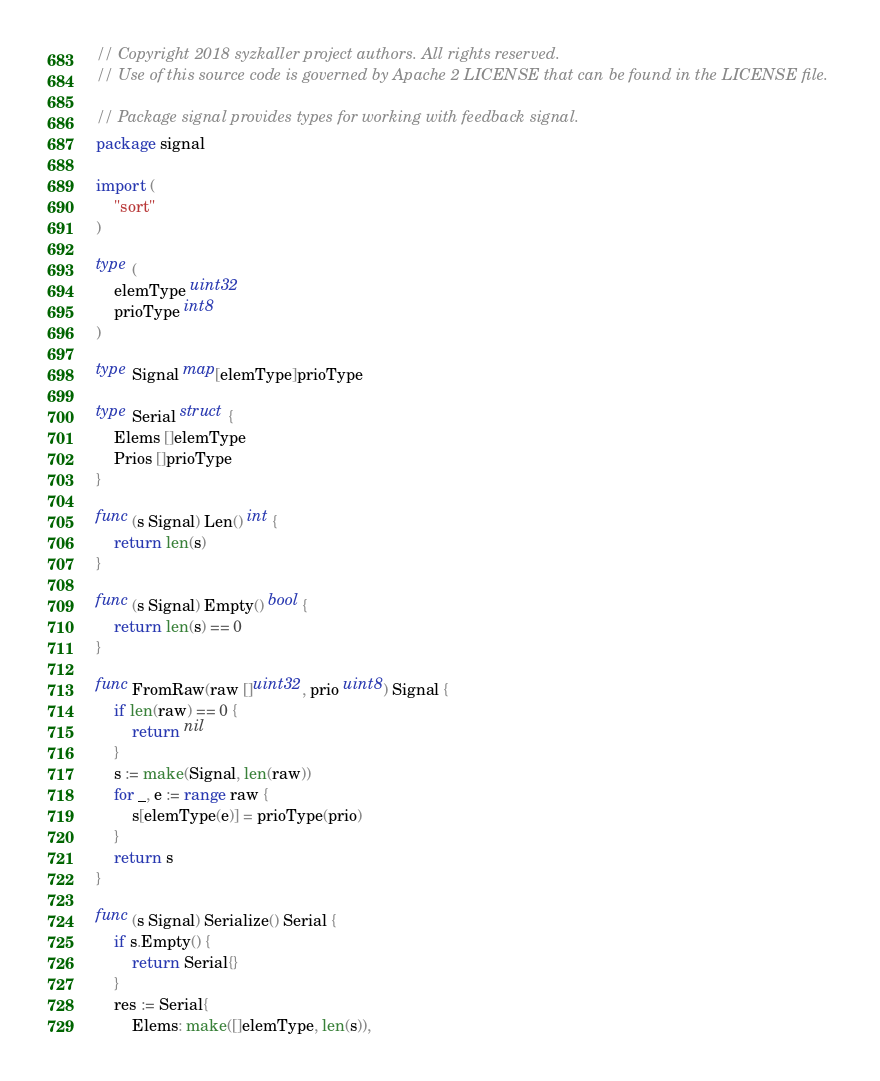Convert code to text. <code><loc_0><loc_0><loc_500><loc_500><_Go_>// Copyright 2018 syzkaller project authors. All rights reserved.
// Use of this source code is governed by Apache 2 LICENSE that can be found in the LICENSE file.

// Package signal provides types for working with feedback signal.
package signal

import (
	"sort"
)

type (
	elemType uint32
	prioType int8
)

type Signal map[elemType]prioType

type Serial struct {
	Elems []elemType
	Prios []prioType
}

func (s Signal) Len() int {
	return len(s)
}

func (s Signal) Empty() bool {
	return len(s) == 0
}

func FromRaw(raw []uint32, prio uint8) Signal {
	if len(raw) == 0 {
		return nil
	}
	s := make(Signal, len(raw))
	for _, e := range raw {
		s[elemType(e)] = prioType(prio)
	}
	return s
}

func (s Signal) Serialize() Serial {
	if s.Empty() {
		return Serial{}
	}
	res := Serial{
		Elems: make([]elemType, len(s)),</code> 